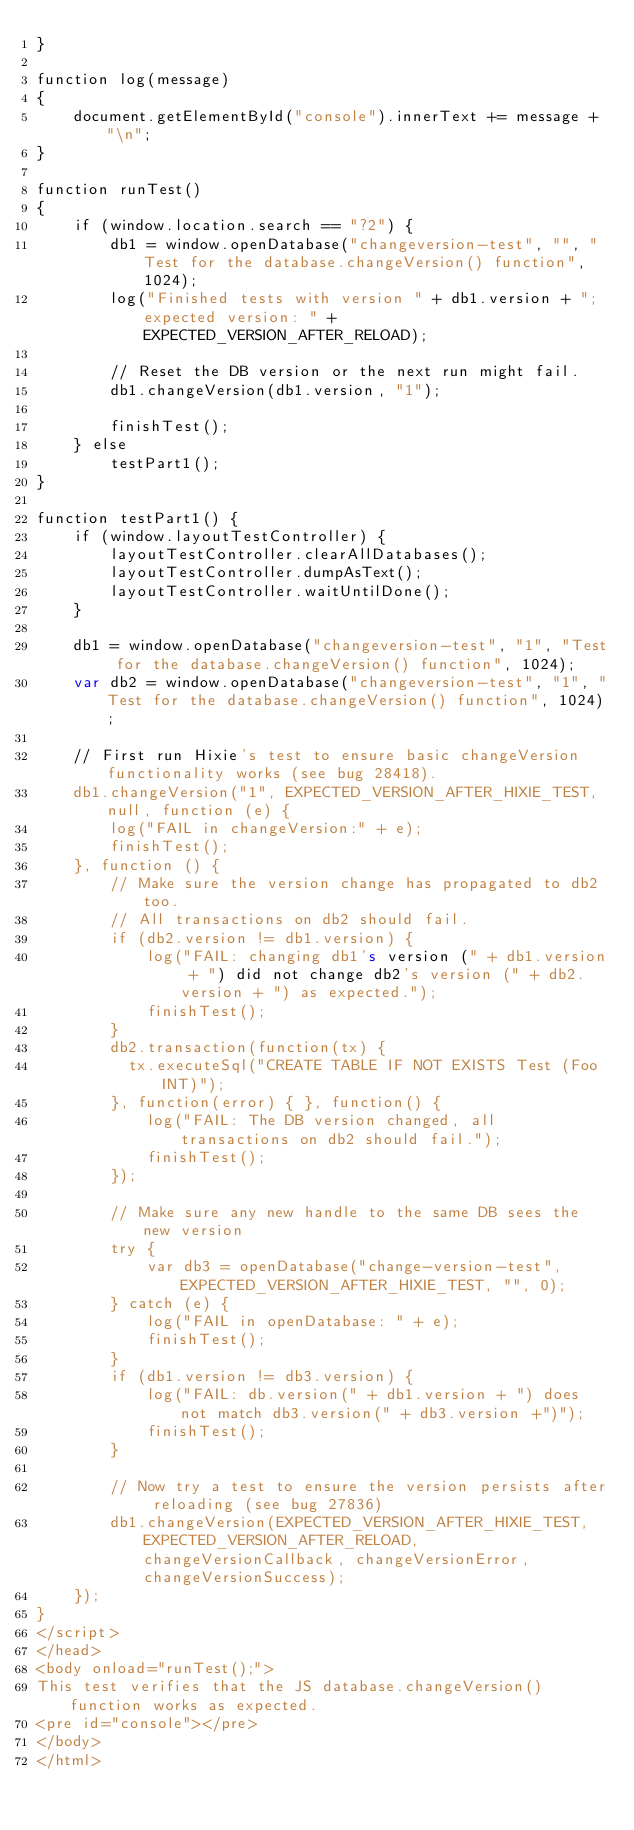<code> <loc_0><loc_0><loc_500><loc_500><_HTML_>}

function log(message)
{
    document.getElementById("console").innerText += message + "\n";
}

function runTest()
{
    if (window.location.search == "?2") {
        db1 = window.openDatabase("changeversion-test", "", "Test for the database.changeVersion() function", 1024);
        log("Finished tests with version " + db1.version + "; expected version: " + EXPECTED_VERSION_AFTER_RELOAD);

        // Reset the DB version or the next run might fail.
        db1.changeVersion(db1.version, "1");

        finishTest();
    } else
        testPart1();
}

function testPart1() {
    if (window.layoutTestController) {
        layoutTestController.clearAllDatabases();
        layoutTestController.dumpAsText();
        layoutTestController.waitUntilDone();
    }

    db1 = window.openDatabase("changeversion-test", "1", "Test for the database.changeVersion() function", 1024);
    var db2 = window.openDatabase("changeversion-test", "1", "Test for the database.changeVersion() function", 1024);

    // First run Hixie's test to ensure basic changeVersion functionality works (see bug 28418).
    db1.changeVersion("1", EXPECTED_VERSION_AFTER_HIXIE_TEST, null, function (e) {
        log("FAIL in changeVersion:" + e);
        finishTest();
    }, function () {
        // Make sure the version change has propagated to db2 too.
        // All transactions on db2 should fail.
        if (db2.version != db1.version) {
            log("FAIL: changing db1's version (" + db1.version + ") did not change db2's version (" + db2.version + ") as expected.");
            finishTest();
        }
        db2.transaction(function(tx) {
          tx.executeSql("CREATE TABLE IF NOT EXISTS Test (Foo INT)");
        }, function(error) { }, function() {
            log("FAIL: The DB version changed, all transactions on db2 should fail.");
            finishTest();
        });

        // Make sure any new handle to the same DB sees the new version
        try {
            var db3 = openDatabase("change-version-test", EXPECTED_VERSION_AFTER_HIXIE_TEST, "", 0);
        } catch (e) {
            log("FAIL in openDatabase: " + e);
            finishTest();
        }
        if (db1.version != db3.version) {
            log("FAIL: db.version(" + db1.version + ") does not match db3.version(" + db3.version +")");
            finishTest();
        }

        // Now try a test to ensure the version persists after reloading (see bug 27836)
        db1.changeVersion(EXPECTED_VERSION_AFTER_HIXIE_TEST, EXPECTED_VERSION_AFTER_RELOAD, changeVersionCallback, changeVersionError, changeVersionSuccess);
    });
}
</script>
</head>
<body onload="runTest();">
This test verifies that the JS database.changeVersion() function works as expected.
<pre id="console"></pre>
</body>
</html>
</code> 